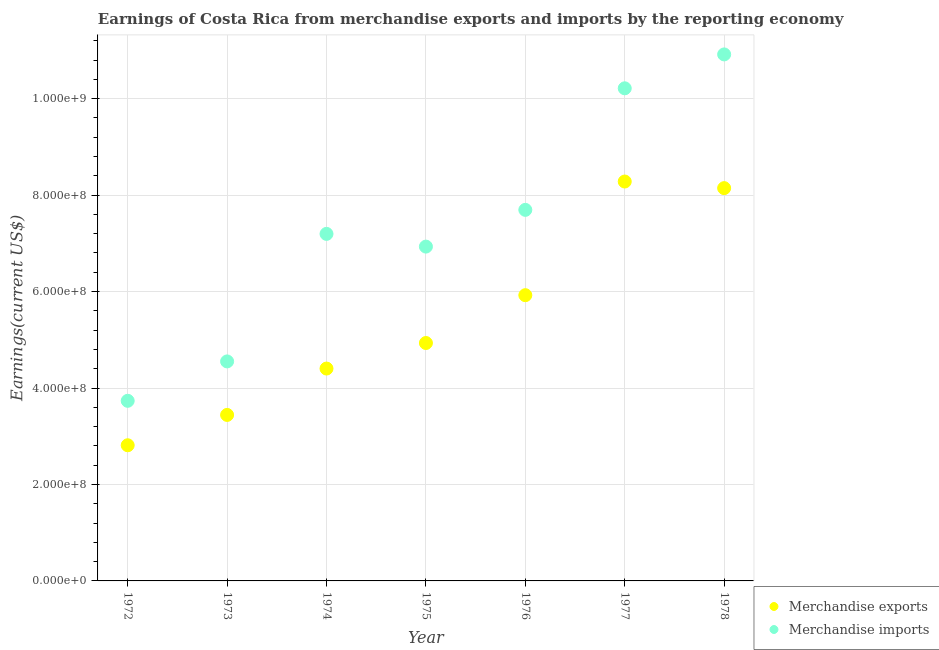How many different coloured dotlines are there?
Give a very brief answer. 2. What is the earnings from merchandise imports in 1976?
Ensure brevity in your answer.  7.69e+08. Across all years, what is the maximum earnings from merchandise exports?
Provide a succinct answer. 8.28e+08. Across all years, what is the minimum earnings from merchandise exports?
Give a very brief answer. 2.81e+08. In which year was the earnings from merchandise imports maximum?
Your answer should be very brief. 1978. In which year was the earnings from merchandise imports minimum?
Offer a terse response. 1972. What is the total earnings from merchandise exports in the graph?
Provide a succinct answer. 3.79e+09. What is the difference between the earnings from merchandise imports in 1974 and that in 1975?
Offer a very short reply. 2.64e+07. What is the difference between the earnings from merchandise exports in 1975 and the earnings from merchandise imports in 1972?
Offer a very short reply. 1.20e+08. What is the average earnings from merchandise exports per year?
Offer a terse response. 5.42e+08. In the year 1978, what is the difference between the earnings from merchandise imports and earnings from merchandise exports?
Offer a terse response. 2.77e+08. In how many years, is the earnings from merchandise exports greater than 1080000000 US$?
Offer a terse response. 0. What is the ratio of the earnings from merchandise imports in 1974 to that in 1976?
Offer a very short reply. 0.94. Is the difference between the earnings from merchandise imports in 1972 and 1974 greater than the difference between the earnings from merchandise exports in 1972 and 1974?
Provide a succinct answer. No. What is the difference between the highest and the second highest earnings from merchandise exports?
Make the answer very short. 1.37e+07. What is the difference between the highest and the lowest earnings from merchandise exports?
Your response must be concise. 5.47e+08. In how many years, is the earnings from merchandise imports greater than the average earnings from merchandise imports taken over all years?
Your answer should be compact. 3. Is the sum of the earnings from merchandise exports in 1974 and 1975 greater than the maximum earnings from merchandise imports across all years?
Offer a terse response. No. Does the earnings from merchandise imports monotonically increase over the years?
Your answer should be very brief. No. Is the earnings from merchandise imports strictly greater than the earnings from merchandise exports over the years?
Your answer should be compact. Yes. What is the difference between two consecutive major ticks on the Y-axis?
Make the answer very short. 2.00e+08. Are the values on the major ticks of Y-axis written in scientific E-notation?
Keep it short and to the point. Yes. Does the graph contain any zero values?
Offer a terse response. No. Does the graph contain grids?
Your answer should be very brief. Yes. How many legend labels are there?
Give a very brief answer. 2. What is the title of the graph?
Keep it short and to the point. Earnings of Costa Rica from merchandise exports and imports by the reporting economy. What is the label or title of the Y-axis?
Your answer should be very brief. Earnings(current US$). What is the Earnings(current US$) of Merchandise exports in 1972?
Give a very brief answer. 2.81e+08. What is the Earnings(current US$) of Merchandise imports in 1972?
Your response must be concise. 3.73e+08. What is the Earnings(current US$) of Merchandise exports in 1973?
Ensure brevity in your answer.  3.44e+08. What is the Earnings(current US$) of Merchandise imports in 1973?
Provide a short and direct response. 4.55e+08. What is the Earnings(current US$) of Merchandise exports in 1974?
Make the answer very short. 4.40e+08. What is the Earnings(current US$) in Merchandise imports in 1974?
Offer a very short reply. 7.20e+08. What is the Earnings(current US$) of Merchandise exports in 1975?
Ensure brevity in your answer.  4.93e+08. What is the Earnings(current US$) in Merchandise imports in 1975?
Give a very brief answer. 6.93e+08. What is the Earnings(current US$) in Merchandise exports in 1976?
Your response must be concise. 5.92e+08. What is the Earnings(current US$) in Merchandise imports in 1976?
Your response must be concise. 7.69e+08. What is the Earnings(current US$) of Merchandise exports in 1977?
Your answer should be compact. 8.28e+08. What is the Earnings(current US$) in Merchandise imports in 1977?
Your answer should be compact. 1.02e+09. What is the Earnings(current US$) of Merchandise exports in 1978?
Your answer should be very brief. 8.14e+08. What is the Earnings(current US$) in Merchandise imports in 1978?
Give a very brief answer. 1.09e+09. Across all years, what is the maximum Earnings(current US$) of Merchandise exports?
Ensure brevity in your answer.  8.28e+08. Across all years, what is the maximum Earnings(current US$) in Merchandise imports?
Offer a very short reply. 1.09e+09. Across all years, what is the minimum Earnings(current US$) in Merchandise exports?
Your response must be concise. 2.81e+08. Across all years, what is the minimum Earnings(current US$) of Merchandise imports?
Keep it short and to the point. 3.73e+08. What is the total Earnings(current US$) of Merchandise exports in the graph?
Offer a terse response. 3.79e+09. What is the total Earnings(current US$) of Merchandise imports in the graph?
Keep it short and to the point. 5.12e+09. What is the difference between the Earnings(current US$) of Merchandise exports in 1972 and that in 1973?
Your answer should be very brief. -6.29e+07. What is the difference between the Earnings(current US$) in Merchandise imports in 1972 and that in 1973?
Provide a short and direct response. -8.17e+07. What is the difference between the Earnings(current US$) of Merchandise exports in 1972 and that in 1974?
Give a very brief answer. -1.59e+08. What is the difference between the Earnings(current US$) in Merchandise imports in 1972 and that in 1974?
Make the answer very short. -3.46e+08. What is the difference between the Earnings(current US$) in Merchandise exports in 1972 and that in 1975?
Give a very brief answer. -2.12e+08. What is the difference between the Earnings(current US$) in Merchandise imports in 1972 and that in 1975?
Provide a succinct answer. -3.20e+08. What is the difference between the Earnings(current US$) in Merchandise exports in 1972 and that in 1976?
Your answer should be compact. -3.11e+08. What is the difference between the Earnings(current US$) in Merchandise imports in 1972 and that in 1976?
Provide a short and direct response. -3.96e+08. What is the difference between the Earnings(current US$) in Merchandise exports in 1972 and that in 1977?
Provide a short and direct response. -5.47e+08. What is the difference between the Earnings(current US$) of Merchandise imports in 1972 and that in 1977?
Provide a succinct answer. -6.48e+08. What is the difference between the Earnings(current US$) in Merchandise exports in 1972 and that in 1978?
Make the answer very short. -5.33e+08. What is the difference between the Earnings(current US$) in Merchandise imports in 1972 and that in 1978?
Offer a terse response. -7.18e+08. What is the difference between the Earnings(current US$) in Merchandise exports in 1973 and that in 1974?
Ensure brevity in your answer.  -9.62e+07. What is the difference between the Earnings(current US$) in Merchandise imports in 1973 and that in 1974?
Your answer should be compact. -2.64e+08. What is the difference between the Earnings(current US$) of Merchandise exports in 1973 and that in 1975?
Offer a very short reply. -1.49e+08. What is the difference between the Earnings(current US$) of Merchandise imports in 1973 and that in 1975?
Make the answer very short. -2.38e+08. What is the difference between the Earnings(current US$) in Merchandise exports in 1973 and that in 1976?
Ensure brevity in your answer.  -2.48e+08. What is the difference between the Earnings(current US$) of Merchandise imports in 1973 and that in 1976?
Give a very brief answer. -3.14e+08. What is the difference between the Earnings(current US$) of Merchandise exports in 1973 and that in 1977?
Provide a succinct answer. -4.84e+08. What is the difference between the Earnings(current US$) in Merchandise imports in 1973 and that in 1977?
Ensure brevity in your answer.  -5.66e+08. What is the difference between the Earnings(current US$) of Merchandise exports in 1973 and that in 1978?
Give a very brief answer. -4.70e+08. What is the difference between the Earnings(current US$) of Merchandise imports in 1973 and that in 1978?
Provide a short and direct response. -6.37e+08. What is the difference between the Earnings(current US$) in Merchandise exports in 1974 and that in 1975?
Your response must be concise. -5.30e+07. What is the difference between the Earnings(current US$) of Merchandise imports in 1974 and that in 1975?
Offer a very short reply. 2.64e+07. What is the difference between the Earnings(current US$) in Merchandise exports in 1974 and that in 1976?
Ensure brevity in your answer.  -1.52e+08. What is the difference between the Earnings(current US$) in Merchandise imports in 1974 and that in 1976?
Your response must be concise. -4.98e+07. What is the difference between the Earnings(current US$) in Merchandise exports in 1974 and that in 1977?
Keep it short and to the point. -3.88e+08. What is the difference between the Earnings(current US$) of Merchandise imports in 1974 and that in 1977?
Your answer should be compact. -3.02e+08. What is the difference between the Earnings(current US$) in Merchandise exports in 1974 and that in 1978?
Offer a terse response. -3.74e+08. What is the difference between the Earnings(current US$) in Merchandise imports in 1974 and that in 1978?
Provide a short and direct response. -3.72e+08. What is the difference between the Earnings(current US$) in Merchandise exports in 1975 and that in 1976?
Make the answer very short. -9.92e+07. What is the difference between the Earnings(current US$) of Merchandise imports in 1975 and that in 1976?
Offer a very short reply. -7.62e+07. What is the difference between the Earnings(current US$) of Merchandise exports in 1975 and that in 1977?
Your answer should be very brief. -3.35e+08. What is the difference between the Earnings(current US$) in Merchandise imports in 1975 and that in 1977?
Give a very brief answer. -3.28e+08. What is the difference between the Earnings(current US$) of Merchandise exports in 1975 and that in 1978?
Provide a short and direct response. -3.21e+08. What is the difference between the Earnings(current US$) of Merchandise imports in 1975 and that in 1978?
Keep it short and to the point. -3.98e+08. What is the difference between the Earnings(current US$) in Merchandise exports in 1976 and that in 1977?
Your answer should be very brief. -2.36e+08. What is the difference between the Earnings(current US$) of Merchandise imports in 1976 and that in 1977?
Make the answer very short. -2.52e+08. What is the difference between the Earnings(current US$) in Merchandise exports in 1976 and that in 1978?
Give a very brief answer. -2.22e+08. What is the difference between the Earnings(current US$) of Merchandise imports in 1976 and that in 1978?
Keep it short and to the point. -3.22e+08. What is the difference between the Earnings(current US$) of Merchandise exports in 1977 and that in 1978?
Give a very brief answer. 1.37e+07. What is the difference between the Earnings(current US$) of Merchandise imports in 1977 and that in 1978?
Ensure brevity in your answer.  -7.03e+07. What is the difference between the Earnings(current US$) of Merchandise exports in 1972 and the Earnings(current US$) of Merchandise imports in 1973?
Your answer should be very brief. -1.74e+08. What is the difference between the Earnings(current US$) in Merchandise exports in 1972 and the Earnings(current US$) in Merchandise imports in 1974?
Your response must be concise. -4.38e+08. What is the difference between the Earnings(current US$) in Merchandise exports in 1972 and the Earnings(current US$) in Merchandise imports in 1975?
Give a very brief answer. -4.12e+08. What is the difference between the Earnings(current US$) in Merchandise exports in 1972 and the Earnings(current US$) in Merchandise imports in 1976?
Keep it short and to the point. -4.88e+08. What is the difference between the Earnings(current US$) of Merchandise exports in 1972 and the Earnings(current US$) of Merchandise imports in 1977?
Offer a very short reply. -7.40e+08. What is the difference between the Earnings(current US$) in Merchandise exports in 1972 and the Earnings(current US$) in Merchandise imports in 1978?
Keep it short and to the point. -8.10e+08. What is the difference between the Earnings(current US$) in Merchandise exports in 1973 and the Earnings(current US$) in Merchandise imports in 1974?
Provide a short and direct response. -3.75e+08. What is the difference between the Earnings(current US$) in Merchandise exports in 1973 and the Earnings(current US$) in Merchandise imports in 1975?
Offer a very short reply. -3.49e+08. What is the difference between the Earnings(current US$) in Merchandise exports in 1973 and the Earnings(current US$) in Merchandise imports in 1976?
Your answer should be compact. -4.25e+08. What is the difference between the Earnings(current US$) in Merchandise exports in 1973 and the Earnings(current US$) in Merchandise imports in 1977?
Your answer should be very brief. -6.77e+08. What is the difference between the Earnings(current US$) of Merchandise exports in 1973 and the Earnings(current US$) of Merchandise imports in 1978?
Provide a short and direct response. -7.48e+08. What is the difference between the Earnings(current US$) of Merchandise exports in 1974 and the Earnings(current US$) of Merchandise imports in 1975?
Provide a short and direct response. -2.53e+08. What is the difference between the Earnings(current US$) in Merchandise exports in 1974 and the Earnings(current US$) in Merchandise imports in 1976?
Provide a short and direct response. -3.29e+08. What is the difference between the Earnings(current US$) in Merchandise exports in 1974 and the Earnings(current US$) in Merchandise imports in 1977?
Your answer should be very brief. -5.81e+08. What is the difference between the Earnings(current US$) of Merchandise exports in 1974 and the Earnings(current US$) of Merchandise imports in 1978?
Make the answer very short. -6.51e+08. What is the difference between the Earnings(current US$) of Merchandise exports in 1975 and the Earnings(current US$) of Merchandise imports in 1976?
Your answer should be compact. -2.76e+08. What is the difference between the Earnings(current US$) in Merchandise exports in 1975 and the Earnings(current US$) in Merchandise imports in 1977?
Keep it short and to the point. -5.28e+08. What is the difference between the Earnings(current US$) of Merchandise exports in 1975 and the Earnings(current US$) of Merchandise imports in 1978?
Ensure brevity in your answer.  -5.98e+08. What is the difference between the Earnings(current US$) of Merchandise exports in 1976 and the Earnings(current US$) of Merchandise imports in 1977?
Provide a short and direct response. -4.29e+08. What is the difference between the Earnings(current US$) in Merchandise exports in 1976 and the Earnings(current US$) in Merchandise imports in 1978?
Make the answer very short. -4.99e+08. What is the difference between the Earnings(current US$) in Merchandise exports in 1977 and the Earnings(current US$) in Merchandise imports in 1978?
Your response must be concise. -2.64e+08. What is the average Earnings(current US$) of Merchandise exports per year?
Your answer should be compact. 5.42e+08. What is the average Earnings(current US$) of Merchandise imports per year?
Ensure brevity in your answer.  7.32e+08. In the year 1972, what is the difference between the Earnings(current US$) of Merchandise exports and Earnings(current US$) of Merchandise imports?
Offer a very short reply. -9.22e+07. In the year 1973, what is the difference between the Earnings(current US$) of Merchandise exports and Earnings(current US$) of Merchandise imports?
Provide a short and direct response. -1.11e+08. In the year 1974, what is the difference between the Earnings(current US$) in Merchandise exports and Earnings(current US$) in Merchandise imports?
Provide a short and direct response. -2.79e+08. In the year 1975, what is the difference between the Earnings(current US$) in Merchandise exports and Earnings(current US$) in Merchandise imports?
Your response must be concise. -2.00e+08. In the year 1976, what is the difference between the Earnings(current US$) of Merchandise exports and Earnings(current US$) of Merchandise imports?
Your answer should be very brief. -1.77e+08. In the year 1977, what is the difference between the Earnings(current US$) in Merchandise exports and Earnings(current US$) in Merchandise imports?
Offer a terse response. -1.93e+08. In the year 1978, what is the difference between the Earnings(current US$) in Merchandise exports and Earnings(current US$) in Merchandise imports?
Your response must be concise. -2.77e+08. What is the ratio of the Earnings(current US$) of Merchandise exports in 1972 to that in 1973?
Offer a terse response. 0.82. What is the ratio of the Earnings(current US$) in Merchandise imports in 1972 to that in 1973?
Keep it short and to the point. 0.82. What is the ratio of the Earnings(current US$) in Merchandise exports in 1972 to that in 1974?
Ensure brevity in your answer.  0.64. What is the ratio of the Earnings(current US$) of Merchandise imports in 1972 to that in 1974?
Your answer should be very brief. 0.52. What is the ratio of the Earnings(current US$) of Merchandise exports in 1972 to that in 1975?
Offer a very short reply. 0.57. What is the ratio of the Earnings(current US$) in Merchandise imports in 1972 to that in 1975?
Your response must be concise. 0.54. What is the ratio of the Earnings(current US$) in Merchandise exports in 1972 to that in 1976?
Offer a terse response. 0.47. What is the ratio of the Earnings(current US$) in Merchandise imports in 1972 to that in 1976?
Provide a succinct answer. 0.49. What is the ratio of the Earnings(current US$) in Merchandise exports in 1972 to that in 1977?
Provide a short and direct response. 0.34. What is the ratio of the Earnings(current US$) in Merchandise imports in 1972 to that in 1977?
Your answer should be compact. 0.37. What is the ratio of the Earnings(current US$) in Merchandise exports in 1972 to that in 1978?
Offer a terse response. 0.35. What is the ratio of the Earnings(current US$) of Merchandise imports in 1972 to that in 1978?
Provide a succinct answer. 0.34. What is the ratio of the Earnings(current US$) of Merchandise exports in 1973 to that in 1974?
Keep it short and to the point. 0.78. What is the ratio of the Earnings(current US$) in Merchandise imports in 1973 to that in 1974?
Your answer should be very brief. 0.63. What is the ratio of the Earnings(current US$) in Merchandise exports in 1973 to that in 1975?
Offer a terse response. 0.7. What is the ratio of the Earnings(current US$) of Merchandise imports in 1973 to that in 1975?
Make the answer very short. 0.66. What is the ratio of the Earnings(current US$) in Merchandise exports in 1973 to that in 1976?
Offer a terse response. 0.58. What is the ratio of the Earnings(current US$) in Merchandise imports in 1973 to that in 1976?
Ensure brevity in your answer.  0.59. What is the ratio of the Earnings(current US$) in Merchandise exports in 1973 to that in 1977?
Provide a short and direct response. 0.42. What is the ratio of the Earnings(current US$) of Merchandise imports in 1973 to that in 1977?
Give a very brief answer. 0.45. What is the ratio of the Earnings(current US$) in Merchandise exports in 1973 to that in 1978?
Your answer should be very brief. 0.42. What is the ratio of the Earnings(current US$) of Merchandise imports in 1973 to that in 1978?
Make the answer very short. 0.42. What is the ratio of the Earnings(current US$) in Merchandise exports in 1974 to that in 1975?
Ensure brevity in your answer.  0.89. What is the ratio of the Earnings(current US$) of Merchandise imports in 1974 to that in 1975?
Your answer should be compact. 1.04. What is the ratio of the Earnings(current US$) of Merchandise exports in 1974 to that in 1976?
Your answer should be compact. 0.74. What is the ratio of the Earnings(current US$) of Merchandise imports in 1974 to that in 1976?
Offer a very short reply. 0.94. What is the ratio of the Earnings(current US$) of Merchandise exports in 1974 to that in 1977?
Your response must be concise. 0.53. What is the ratio of the Earnings(current US$) in Merchandise imports in 1974 to that in 1977?
Keep it short and to the point. 0.7. What is the ratio of the Earnings(current US$) in Merchandise exports in 1974 to that in 1978?
Offer a terse response. 0.54. What is the ratio of the Earnings(current US$) of Merchandise imports in 1974 to that in 1978?
Ensure brevity in your answer.  0.66. What is the ratio of the Earnings(current US$) in Merchandise exports in 1975 to that in 1976?
Offer a terse response. 0.83. What is the ratio of the Earnings(current US$) of Merchandise imports in 1975 to that in 1976?
Offer a very short reply. 0.9. What is the ratio of the Earnings(current US$) of Merchandise exports in 1975 to that in 1977?
Give a very brief answer. 0.6. What is the ratio of the Earnings(current US$) of Merchandise imports in 1975 to that in 1977?
Provide a short and direct response. 0.68. What is the ratio of the Earnings(current US$) of Merchandise exports in 1975 to that in 1978?
Give a very brief answer. 0.61. What is the ratio of the Earnings(current US$) of Merchandise imports in 1975 to that in 1978?
Offer a very short reply. 0.64. What is the ratio of the Earnings(current US$) in Merchandise exports in 1976 to that in 1977?
Give a very brief answer. 0.72. What is the ratio of the Earnings(current US$) of Merchandise imports in 1976 to that in 1977?
Keep it short and to the point. 0.75. What is the ratio of the Earnings(current US$) of Merchandise exports in 1976 to that in 1978?
Offer a terse response. 0.73. What is the ratio of the Earnings(current US$) in Merchandise imports in 1976 to that in 1978?
Your response must be concise. 0.7. What is the ratio of the Earnings(current US$) in Merchandise exports in 1977 to that in 1978?
Provide a short and direct response. 1.02. What is the ratio of the Earnings(current US$) in Merchandise imports in 1977 to that in 1978?
Make the answer very short. 0.94. What is the difference between the highest and the second highest Earnings(current US$) of Merchandise exports?
Provide a succinct answer. 1.37e+07. What is the difference between the highest and the second highest Earnings(current US$) in Merchandise imports?
Your response must be concise. 7.03e+07. What is the difference between the highest and the lowest Earnings(current US$) in Merchandise exports?
Your response must be concise. 5.47e+08. What is the difference between the highest and the lowest Earnings(current US$) in Merchandise imports?
Ensure brevity in your answer.  7.18e+08. 